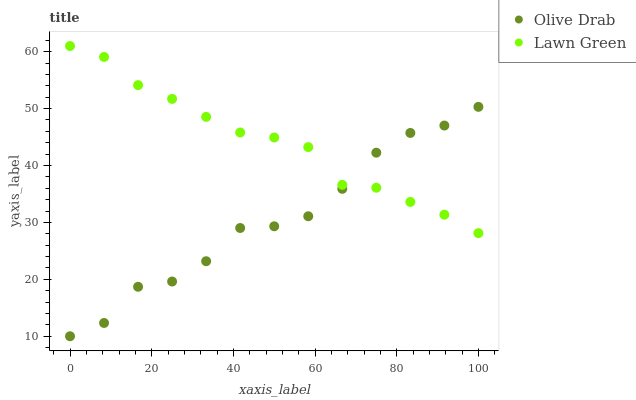Does Olive Drab have the minimum area under the curve?
Answer yes or no. Yes. Does Lawn Green have the maximum area under the curve?
Answer yes or no. Yes. Does Olive Drab have the maximum area under the curve?
Answer yes or no. No. Is Lawn Green the smoothest?
Answer yes or no. Yes. Is Olive Drab the roughest?
Answer yes or no. Yes. Is Olive Drab the smoothest?
Answer yes or no. No. Does Olive Drab have the lowest value?
Answer yes or no. Yes. Does Lawn Green have the highest value?
Answer yes or no. Yes. Does Olive Drab have the highest value?
Answer yes or no. No. Does Olive Drab intersect Lawn Green?
Answer yes or no. Yes. Is Olive Drab less than Lawn Green?
Answer yes or no. No. Is Olive Drab greater than Lawn Green?
Answer yes or no. No. 